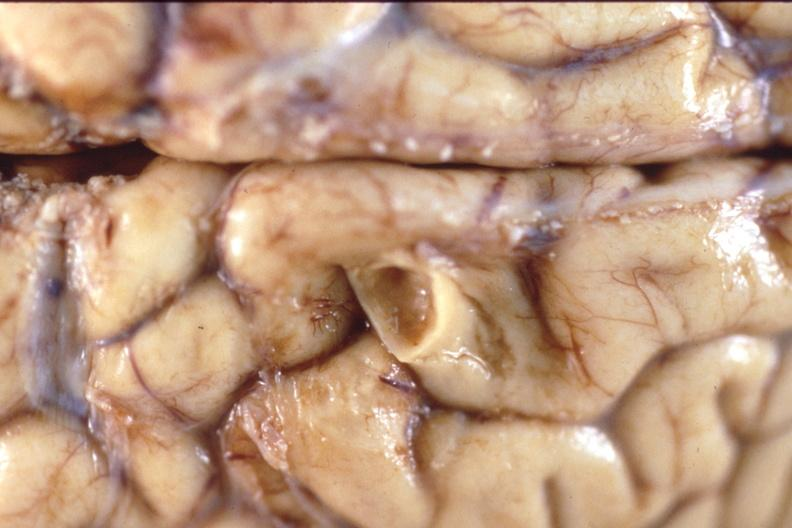s matting history of this case present?
Answer the question using a single word or phrase. No 